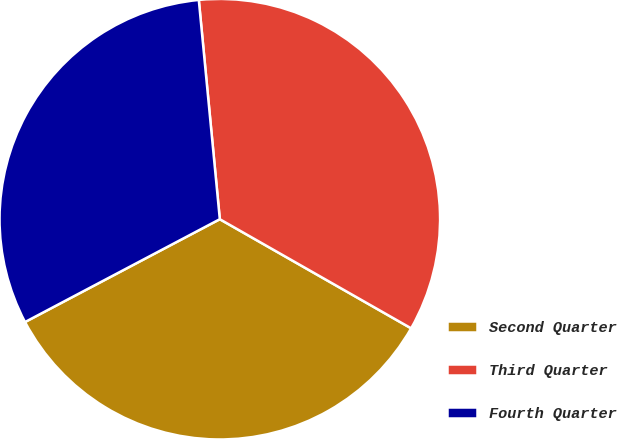Convert chart to OTSL. <chart><loc_0><loc_0><loc_500><loc_500><pie_chart><fcel>Second Quarter<fcel>Third Quarter<fcel>Fourth Quarter<nl><fcel>34.02%<fcel>34.77%<fcel>31.21%<nl></chart> 